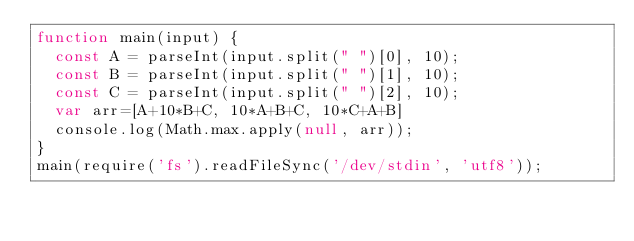<code> <loc_0><loc_0><loc_500><loc_500><_JavaScript_>function main(input) {
  const A = parseInt(input.split(" ")[0], 10);
  const B = parseInt(input.split(" ")[1], 10);
  const C = parseInt(input.split(" ")[2], 10);
  var arr=[A+10*B+C, 10*A+B+C, 10*C+A+B]
  console.log(Math.max.apply(null, arr));
}
main(require('fs').readFileSync('/dev/stdin', 'utf8'));</code> 